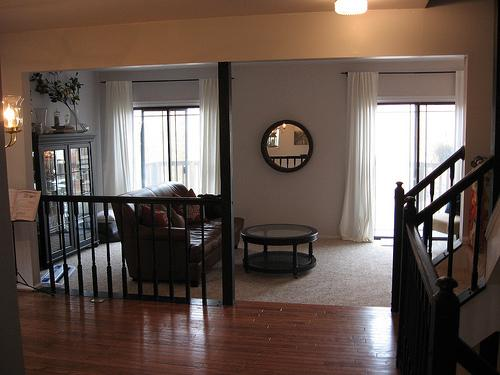What type of furniture holds the decorative plant in the image? A curio cabinet with glass doors holds the decorative plant in the image. List two decorative elements seen on the window in the image. White linen drapes and white curtains are two decorative elements adorning the window in the image. Comment on the overall color scheme of the living room and how it impacts the atmosphere. The living room features a neutral color scheme with shades of brown, grey, and white, creating a calming and inviting atmosphere for relaxation and socializing. Mention a specific color used for one of the objects in the image and how it adds contrast. The black frame of the mirror on the wall contrasts with the grey colored wall, adding visual interest and depth to the space. Describe an aspect of the image that showcases a modern design element. The round glass coffee table with black wood and glass is a modern design element, adding elegance and contemporary style to the living room. Identify two objects that serve as functional decorations in the room. The round mirror on the wall and the tall flowers in a large vase on the cabinet are functional decorations in the room. Describe the type of flooring in the image and its appearance. The flooring is dark wood, featuring a clean and polished appearance, complemented by a beige carpet in parts of the living room. Briefly explain the main purpose of the living room in the image. The living room is designed for relaxation, featuring a comfortable couch, a glass coffee table, and a cozy ambiance created by soft lighting and neutral colors. Which objects in the image provide lighting to the living room? The light on the ceiling and the light on the wall provide lighting to the living room. In your own words, describe the materials and colors used for the couch in the room. The couch is made of brown leather, providing a cozy and sophisticated touch to the living room's design. 